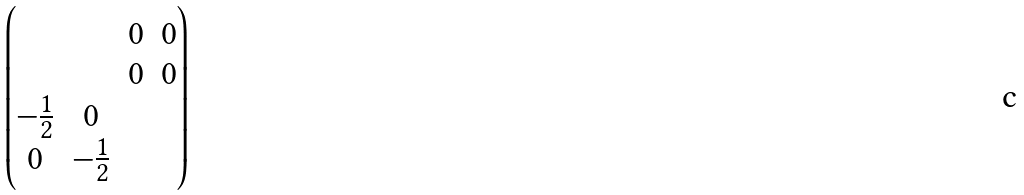Convert formula to latex. <formula><loc_0><loc_0><loc_500><loc_500>\begin{pmatrix} & & 0 & 0 \\ & & 0 & 0 \\ - \frac { 1 } { 2 } & 0 & & \\ 0 & - \frac { 1 } { 2 } & & \end{pmatrix}</formula> 